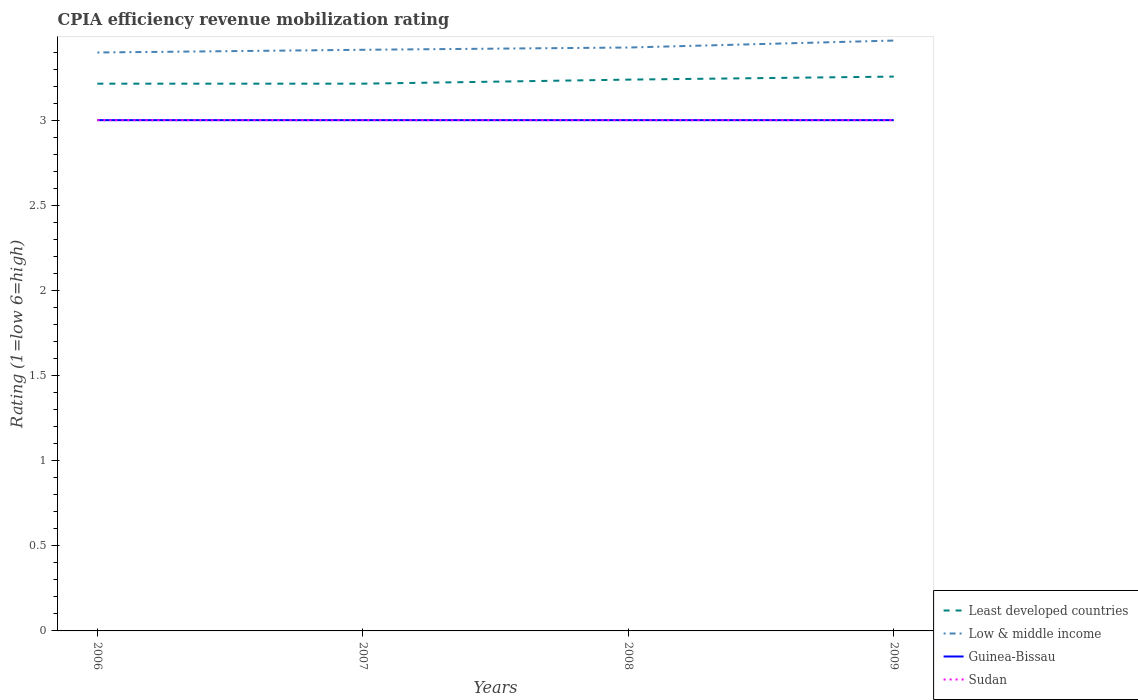Does the line corresponding to Least developed countries intersect with the line corresponding to Guinea-Bissau?
Make the answer very short. No. Across all years, what is the maximum CPIA rating in Sudan?
Your answer should be compact. 3. What is the total CPIA rating in Low & middle income in the graph?
Your answer should be very brief. -0.03. What is the difference between the highest and the second highest CPIA rating in Least developed countries?
Ensure brevity in your answer.  0.04. What is the difference between the highest and the lowest CPIA rating in Least developed countries?
Provide a succinct answer. 2. Is the CPIA rating in Least developed countries strictly greater than the CPIA rating in Guinea-Bissau over the years?
Provide a short and direct response. No. How many lines are there?
Offer a terse response. 4. How many years are there in the graph?
Give a very brief answer. 4. Does the graph contain grids?
Provide a succinct answer. No. Where does the legend appear in the graph?
Provide a short and direct response. Bottom right. How many legend labels are there?
Provide a short and direct response. 4. How are the legend labels stacked?
Offer a terse response. Vertical. What is the title of the graph?
Provide a succinct answer. CPIA efficiency revenue mobilization rating. What is the label or title of the X-axis?
Ensure brevity in your answer.  Years. What is the label or title of the Y-axis?
Your answer should be very brief. Rating (1=low 6=high). What is the Rating (1=low 6=high) of Least developed countries in 2006?
Provide a succinct answer. 3.21. What is the Rating (1=low 6=high) in Low & middle income in 2006?
Your response must be concise. 3.4. What is the Rating (1=low 6=high) in Guinea-Bissau in 2006?
Offer a very short reply. 3. What is the Rating (1=low 6=high) in Least developed countries in 2007?
Keep it short and to the point. 3.21. What is the Rating (1=low 6=high) in Low & middle income in 2007?
Offer a very short reply. 3.41. What is the Rating (1=low 6=high) in Guinea-Bissau in 2007?
Provide a succinct answer. 3. What is the Rating (1=low 6=high) of Least developed countries in 2008?
Provide a short and direct response. 3.24. What is the Rating (1=low 6=high) in Low & middle income in 2008?
Provide a succinct answer. 3.43. What is the Rating (1=low 6=high) in Guinea-Bissau in 2008?
Give a very brief answer. 3. What is the Rating (1=low 6=high) of Sudan in 2008?
Your answer should be very brief. 3. What is the Rating (1=low 6=high) of Least developed countries in 2009?
Give a very brief answer. 3.26. What is the Rating (1=low 6=high) in Low & middle income in 2009?
Ensure brevity in your answer.  3.47. Across all years, what is the maximum Rating (1=low 6=high) in Least developed countries?
Offer a very short reply. 3.26. Across all years, what is the maximum Rating (1=low 6=high) of Low & middle income?
Offer a very short reply. 3.47. Across all years, what is the maximum Rating (1=low 6=high) in Sudan?
Your answer should be compact. 3. Across all years, what is the minimum Rating (1=low 6=high) in Least developed countries?
Your answer should be very brief. 3.21. Across all years, what is the minimum Rating (1=low 6=high) in Low & middle income?
Make the answer very short. 3.4. What is the total Rating (1=low 6=high) in Least developed countries in the graph?
Make the answer very short. 12.92. What is the total Rating (1=low 6=high) in Low & middle income in the graph?
Ensure brevity in your answer.  13.71. What is the difference between the Rating (1=low 6=high) of Low & middle income in 2006 and that in 2007?
Offer a terse response. -0.02. What is the difference between the Rating (1=low 6=high) in Guinea-Bissau in 2006 and that in 2007?
Give a very brief answer. 0. What is the difference between the Rating (1=low 6=high) in Sudan in 2006 and that in 2007?
Your answer should be very brief. 0. What is the difference between the Rating (1=low 6=high) of Least developed countries in 2006 and that in 2008?
Make the answer very short. -0.02. What is the difference between the Rating (1=low 6=high) of Low & middle income in 2006 and that in 2008?
Make the answer very short. -0.03. What is the difference between the Rating (1=low 6=high) in Least developed countries in 2006 and that in 2009?
Offer a terse response. -0.04. What is the difference between the Rating (1=low 6=high) in Low & middle income in 2006 and that in 2009?
Make the answer very short. -0.07. What is the difference between the Rating (1=low 6=high) in Guinea-Bissau in 2006 and that in 2009?
Your answer should be compact. 0. What is the difference between the Rating (1=low 6=high) in Sudan in 2006 and that in 2009?
Offer a very short reply. 0. What is the difference between the Rating (1=low 6=high) of Least developed countries in 2007 and that in 2008?
Offer a very short reply. -0.02. What is the difference between the Rating (1=low 6=high) in Low & middle income in 2007 and that in 2008?
Keep it short and to the point. -0.01. What is the difference between the Rating (1=low 6=high) of Least developed countries in 2007 and that in 2009?
Keep it short and to the point. -0.04. What is the difference between the Rating (1=low 6=high) of Low & middle income in 2007 and that in 2009?
Offer a very short reply. -0.05. What is the difference between the Rating (1=low 6=high) of Sudan in 2007 and that in 2009?
Provide a succinct answer. 0. What is the difference between the Rating (1=low 6=high) of Least developed countries in 2008 and that in 2009?
Keep it short and to the point. -0.02. What is the difference between the Rating (1=low 6=high) of Low & middle income in 2008 and that in 2009?
Keep it short and to the point. -0.04. What is the difference between the Rating (1=low 6=high) in Least developed countries in 2006 and the Rating (1=low 6=high) in Low & middle income in 2007?
Give a very brief answer. -0.2. What is the difference between the Rating (1=low 6=high) in Least developed countries in 2006 and the Rating (1=low 6=high) in Guinea-Bissau in 2007?
Provide a short and direct response. 0.21. What is the difference between the Rating (1=low 6=high) in Least developed countries in 2006 and the Rating (1=low 6=high) in Sudan in 2007?
Offer a very short reply. 0.21. What is the difference between the Rating (1=low 6=high) in Low & middle income in 2006 and the Rating (1=low 6=high) in Guinea-Bissau in 2007?
Offer a very short reply. 0.4. What is the difference between the Rating (1=low 6=high) in Low & middle income in 2006 and the Rating (1=low 6=high) in Sudan in 2007?
Your answer should be compact. 0.4. What is the difference between the Rating (1=low 6=high) in Guinea-Bissau in 2006 and the Rating (1=low 6=high) in Sudan in 2007?
Make the answer very short. 0. What is the difference between the Rating (1=low 6=high) of Least developed countries in 2006 and the Rating (1=low 6=high) of Low & middle income in 2008?
Make the answer very short. -0.21. What is the difference between the Rating (1=low 6=high) of Least developed countries in 2006 and the Rating (1=low 6=high) of Guinea-Bissau in 2008?
Your response must be concise. 0.21. What is the difference between the Rating (1=low 6=high) of Least developed countries in 2006 and the Rating (1=low 6=high) of Sudan in 2008?
Give a very brief answer. 0.21. What is the difference between the Rating (1=low 6=high) of Low & middle income in 2006 and the Rating (1=low 6=high) of Guinea-Bissau in 2008?
Provide a short and direct response. 0.4. What is the difference between the Rating (1=low 6=high) of Low & middle income in 2006 and the Rating (1=low 6=high) of Sudan in 2008?
Provide a short and direct response. 0.4. What is the difference between the Rating (1=low 6=high) of Guinea-Bissau in 2006 and the Rating (1=low 6=high) of Sudan in 2008?
Your answer should be compact. 0. What is the difference between the Rating (1=low 6=high) of Least developed countries in 2006 and the Rating (1=low 6=high) of Low & middle income in 2009?
Give a very brief answer. -0.25. What is the difference between the Rating (1=low 6=high) of Least developed countries in 2006 and the Rating (1=low 6=high) of Guinea-Bissau in 2009?
Make the answer very short. 0.21. What is the difference between the Rating (1=low 6=high) of Least developed countries in 2006 and the Rating (1=low 6=high) of Sudan in 2009?
Make the answer very short. 0.21. What is the difference between the Rating (1=low 6=high) of Low & middle income in 2006 and the Rating (1=low 6=high) of Guinea-Bissau in 2009?
Your answer should be compact. 0.4. What is the difference between the Rating (1=low 6=high) in Low & middle income in 2006 and the Rating (1=low 6=high) in Sudan in 2009?
Offer a terse response. 0.4. What is the difference between the Rating (1=low 6=high) in Guinea-Bissau in 2006 and the Rating (1=low 6=high) in Sudan in 2009?
Provide a succinct answer. 0. What is the difference between the Rating (1=low 6=high) of Least developed countries in 2007 and the Rating (1=low 6=high) of Low & middle income in 2008?
Your answer should be very brief. -0.21. What is the difference between the Rating (1=low 6=high) of Least developed countries in 2007 and the Rating (1=low 6=high) of Guinea-Bissau in 2008?
Provide a succinct answer. 0.21. What is the difference between the Rating (1=low 6=high) in Least developed countries in 2007 and the Rating (1=low 6=high) in Sudan in 2008?
Your response must be concise. 0.21. What is the difference between the Rating (1=low 6=high) in Low & middle income in 2007 and the Rating (1=low 6=high) in Guinea-Bissau in 2008?
Offer a very short reply. 0.41. What is the difference between the Rating (1=low 6=high) in Low & middle income in 2007 and the Rating (1=low 6=high) in Sudan in 2008?
Your answer should be compact. 0.41. What is the difference between the Rating (1=low 6=high) in Guinea-Bissau in 2007 and the Rating (1=low 6=high) in Sudan in 2008?
Provide a short and direct response. 0. What is the difference between the Rating (1=low 6=high) of Least developed countries in 2007 and the Rating (1=low 6=high) of Low & middle income in 2009?
Ensure brevity in your answer.  -0.25. What is the difference between the Rating (1=low 6=high) of Least developed countries in 2007 and the Rating (1=low 6=high) of Guinea-Bissau in 2009?
Offer a terse response. 0.21. What is the difference between the Rating (1=low 6=high) of Least developed countries in 2007 and the Rating (1=low 6=high) of Sudan in 2009?
Make the answer very short. 0.21. What is the difference between the Rating (1=low 6=high) in Low & middle income in 2007 and the Rating (1=low 6=high) in Guinea-Bissau in 2009?
Your response must be concise. 0.41. What is the difference between the Rating (1=low 6=high) of Low & middle income in 2007 and the Rating (1=low 6=high) of Sudan in 2009?
Your response must be concise. 0.41. What is the difference between the Rating (1=low 6=high) of Least developed countries in 2008 and the Rating (1=low 6=high) of Low & middle income in 2009?
Provide a short and direct response. -0.23. What is the difference between the Rating (1=low 6=high) in Least developed countries in 2008 and the Rating (1=low 6=high) in Guinea-Bissau in 2009?
Your response must be concise. 0.24. What is the difference between the Rating (1=low 6=high) in Least developed countries in 2008 and the Rating (1=low 6=high) in Sudan in 2009?
Provide a succinct answer. 0.24. What is the difference between the Rating (1=low 6=high) in Low & middle income in 2008 and the Rating (1=low 6=high) in Guinea-Bissau in 2009?
Make the answer very short. 0.43. What is the difference between the Rating (1=low 6=high) of Low & middle income in 2008 and the Rating (1=low 6=high) of Sudan in 2009?
Offer a very short reply. 0.43. What is the difference between the Rating (1=low 6=high) in Guinea-Bissau in 2008 and the Rating (1=low 6=high) in Sudan in 2009?
Offer a very short reply. 0. What is the average Rating (1=low 6=high) in Least developed countries per year?
Make the answer very short. 3.23. What is the average Rating (1=low 6=high) of Low & middle income per year?
Your answer should be compact. 3.43. In the year 2006, what is the difference between the Rating (1=low 6=high) in Least developed countries and Rating (1=low 6=high) in Low & middle income?
Your response must be concise. -0.18. In the year 2006, what is the difference between the Rating (1=low 6=high) of Least developed countries and Rating (1=low 6=high) of Guinea-Bissau?
Provide a succinct answer. 0.21. In the year 2006, what is the difference between the Rating (1=low 6=high) of Least developed countries and Rating (1=low 6=high) of Sudan?
Ensure brevity in your answer.  0.21. In the year 2006, what is the difference between the Rating (1=low 6=high) in Low & middle income and Rating (1=low 6=high) in Guinea-Bissau?
Keep it short and to the point. 0.4. In the year 2006, what is the difference between the Rating (1=low 6=high) in Low & middle income and Rating (1=low 6=high) in Sudan?
Provide a short and direct response. 0.4. In the year 2007, what is the difference between the Rating (1=low 6=high) in Least developed countries and Rating (1=low 6=high) in Low & middle income?
Ensure brevity in your answer.  -0.2. In the year 2007, what is the difference between the Rating (1=low 6=high) of Least developed countries and Rating (1=low 6=high) of Guinea-Bissau?
Your answer should be very brief. 0.21. In the year 2007, what is the difference between the Rating (1=low 6=high) in Least developed countries and Rating (1=low 6=high) in Sudan?
Your answer should be very brief. 0.21. In the year 2007, what is the difference between the Rating (1=low 6=high) of Low & middle income and Rating (1=low 6=high) of Guinea-Bissau?
Your answer should be very brief. 0.41. In the year 2007, what is the difference between the Rating (1=low 6=high) in Low & middle income and Rating (1=low 6=high) in Sudan?
Provide a short and direct response. 0.41. In the year 2008, what is the difference between the Rating (1=low 6=high) of Least developed countries and Rating (1=low 6=high) of Low & middle income?
Keep it short and to the point. -0.19. In the year 2008, what is the difference between the Rating (1=low 6=high) in Least developed countries and Rating (1=low 6=high) in Guinea-Bissau?
Make the answer very short. 0.24. In the year 2008, what is the difference between the Rating (1=low 6=high) in Least developed countries and Rating (1=low 6=high) in Sudan?
Offer a very short reply. 0.24. In the year 2008, what is the difference between the Rating (1=low 6=high) of Low & middle income and Rating (1=low 6=high) of Guinea-Bissau?
Provide a short and direct response. 0.43. In the year 2008, what is the difference between the Rating (1=low 6=high) of Low & middle income and Rating (1=low 6=high) of Sudan?
Offer a very short reply. 0.43. In the year 2008, what is the difference between the Rating (1=low 6=high) of Guinea-Bissau and Rating (1=low 6=high) of Sudan?
Offer a very short reply. 0. In the year 2009, what is the difference between the Rating (1=low 6=high) of Least developed countries and Rating (1=low 6=high) of Low & middle income?
Offer a terse response. -0.21. In the year 2009, what is the difference between the Rating (1=low 6=high) of Least developed countries and Rating (1=low 6=high) of Guinea-Bissau?
Offer a terse response. 0.26. In the year 2009, what is the difference between the Rating (1=low 6=high) of Least developed countries and Rating (1=low 6=high) of Sudan?
Ensure brevity in your answer.  0.26. In the year 2009, what is the difference between the Rating (1=low 6=high) of Low & middle income and Rating (1=low 6=high) of Guinea-Bissau?
Provide a short and direct response. 0.47. In the year 2009, what is the difference between the Rating (1=low 6=high) of Low & middle income and Rating (1=low 6=high) of Sudan?
Offer a terse response. 0.47. What is the ratio of the Rating (1=low 6=high) in Low & middle income in 2006 to that in 2007?
Keep it short and to the point. 1. What is the ratio of the Rating (1=low 6=high) of Low & middle income in 2006 to that in 2008?
Provide a short and direct response. 0.99. What is the ratio of the Rating (1=low 6=high) in Guinea-Bissau in 2006 to that in 2008?
Make the answer very short. 1. What is the ratio of the Rating (1=low 6=high) in Sudan in 2006 to that in 2008?
Provide a succinct answer. 1. What is the ratio of the Rating (1=low 6=high) in Least developed countries in 2006 to that in 2009?
Offer a very short reply. 0.99. What is the ratio of the Rating (1=low 6=high) of Low & middle income in 2006 to that in 2009?
Your response must be concise. 0.98. What is the ratio of the Rating (1=low 6=high) in Sudan in 2006 to that in 2009?
Ensure brevity in your answer.  1. What is the ratio of the Rating (1=low 6=high) of Least developed countries in 2007 to that in 2009?
Provide a short and direct response. 0.99. What is the ratio of the Rating (1=low 6=high) in Low & middle income in 2007 to that in 2009?
Your answer should be very brief. 0.98. What is the ratio of the Rating (1=low 6=high) in Guinea-Bissau in 2007 to that in 2009?
Your answer should be very brief. 1. What is the ratio of the Rating (1=low 6=high) in Sudan in 2007 to that in 2009?
Make the answer very short. 1. What is the ratio of the Rating (1=low 6=high) in Low & middle income in 2008 to that in 2009?
Provide a succinct answer. 0.99. What is the ratio of the Rating (1=low 6=high) of Guinea-Bissau in 2008 to that in 2009?
Offer a terse response. 1. What is the difference between the highest and the second highest Rating (1=low 6=high) of Least developed countries?
Your answer should be very brief. 0.02. What is the difference between the highest and the second highest Rating (1=low 6=high) of Low & middle income?
Your answer should be compact. 0.04. What is the difference between the highest and the lowest Rating (1=low 6=high) in Least developed countries?
Offer a very short reply. 0.04. What is the difference between the highest and the lowest Rating (1=low 6=high) in Low & middle income?
Provide a succinct answer. 0.07. What is the difference between the highest and the lowest Rating (1=low 6=high) of Guinea-Bissau?
Provide a short and direct response. 0. 